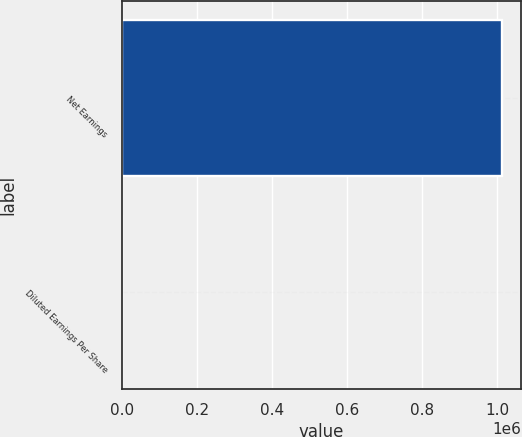Convert chart. <chart><loc_0><loc_0><loc_500><loc_500><bar_chart><fcel>Net Earnings<fcel>Diluted Earnings Per Share<nl><fcel>1.01214e+06<fcel>1.86<nl></chart> 